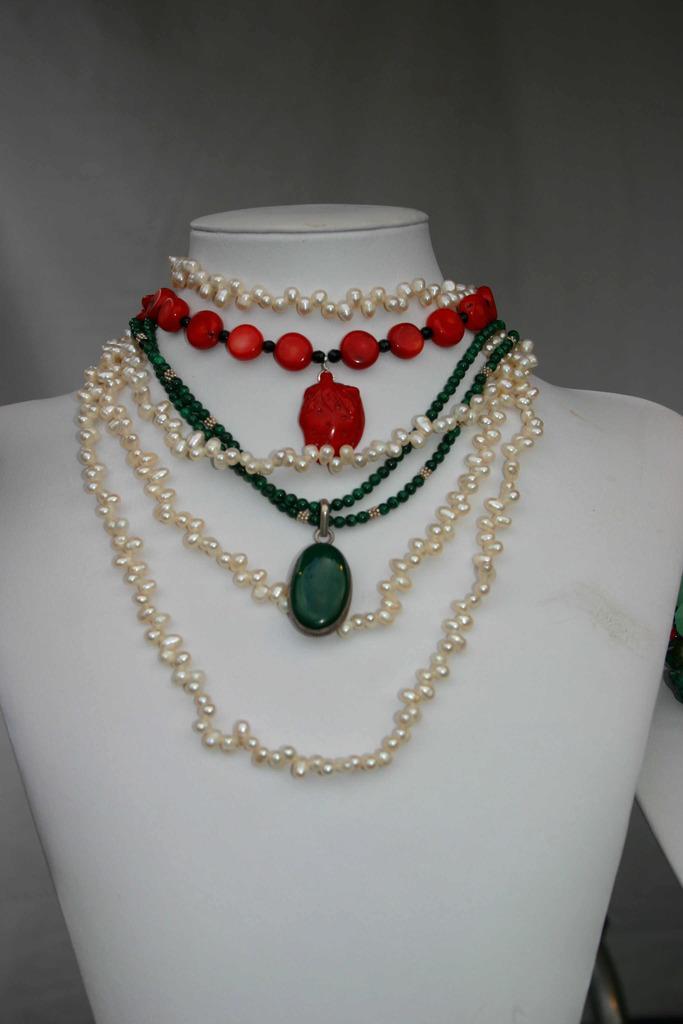Describe this image in one or two sentences. In this image I can see a jewelry stand on which some pearl necklace and other necklaces with colored beads are being displayed. 